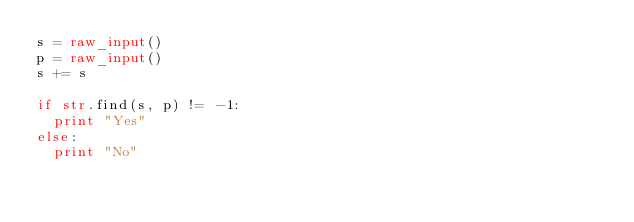Convert code to text. <code><loc_0><loc_0><loc_500><loc_500><_Python_>s = raw_input()
p = raw_input()
s += s

if str.find(s, p) != -1:
  print "Yes"
else:
  print "No"</code> 